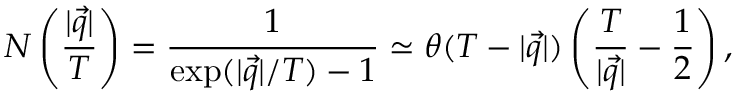Convert formula to latex. <formula><loc_0><loc_0><loc_500><loc_500>N \left ( \frac { | \vec { q } | } { T } \right ) = \frac { 1 } { \exp ( | \vec { q } | / T ) - 1 } \simeq \theta ( T - | \vec { q } | ) \left ( \frac { T } { | \vec { q } | } - \frac { 1 } { 2 } \right ) ,</formula> 